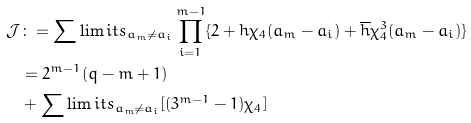<formula> <loc_0><loc_0><loc_500><loc_500>\mathcal { J } & \colon = \sum \lim i t s _ { a _ { m } \neq a _ { i } } \prod _ { i = 1 } ^ { m - 1 } \{ 2 + h \chi _ { 4 } ( a _ { m } - a _ { i } ) + \overline { h } \chi _ { 4 } ^ { 3 } ( a _ { m } - a _ { i } ) \} \\ & = 2 ^ { m - 1 } ( q - m + 1 ) \\ & + \sum \lim i t s _ { a _ { m } \neq a _ { i } } [ ( 3 ^ { m - 1 } - 1 ) \chi _ { 4 } ]</formula> 